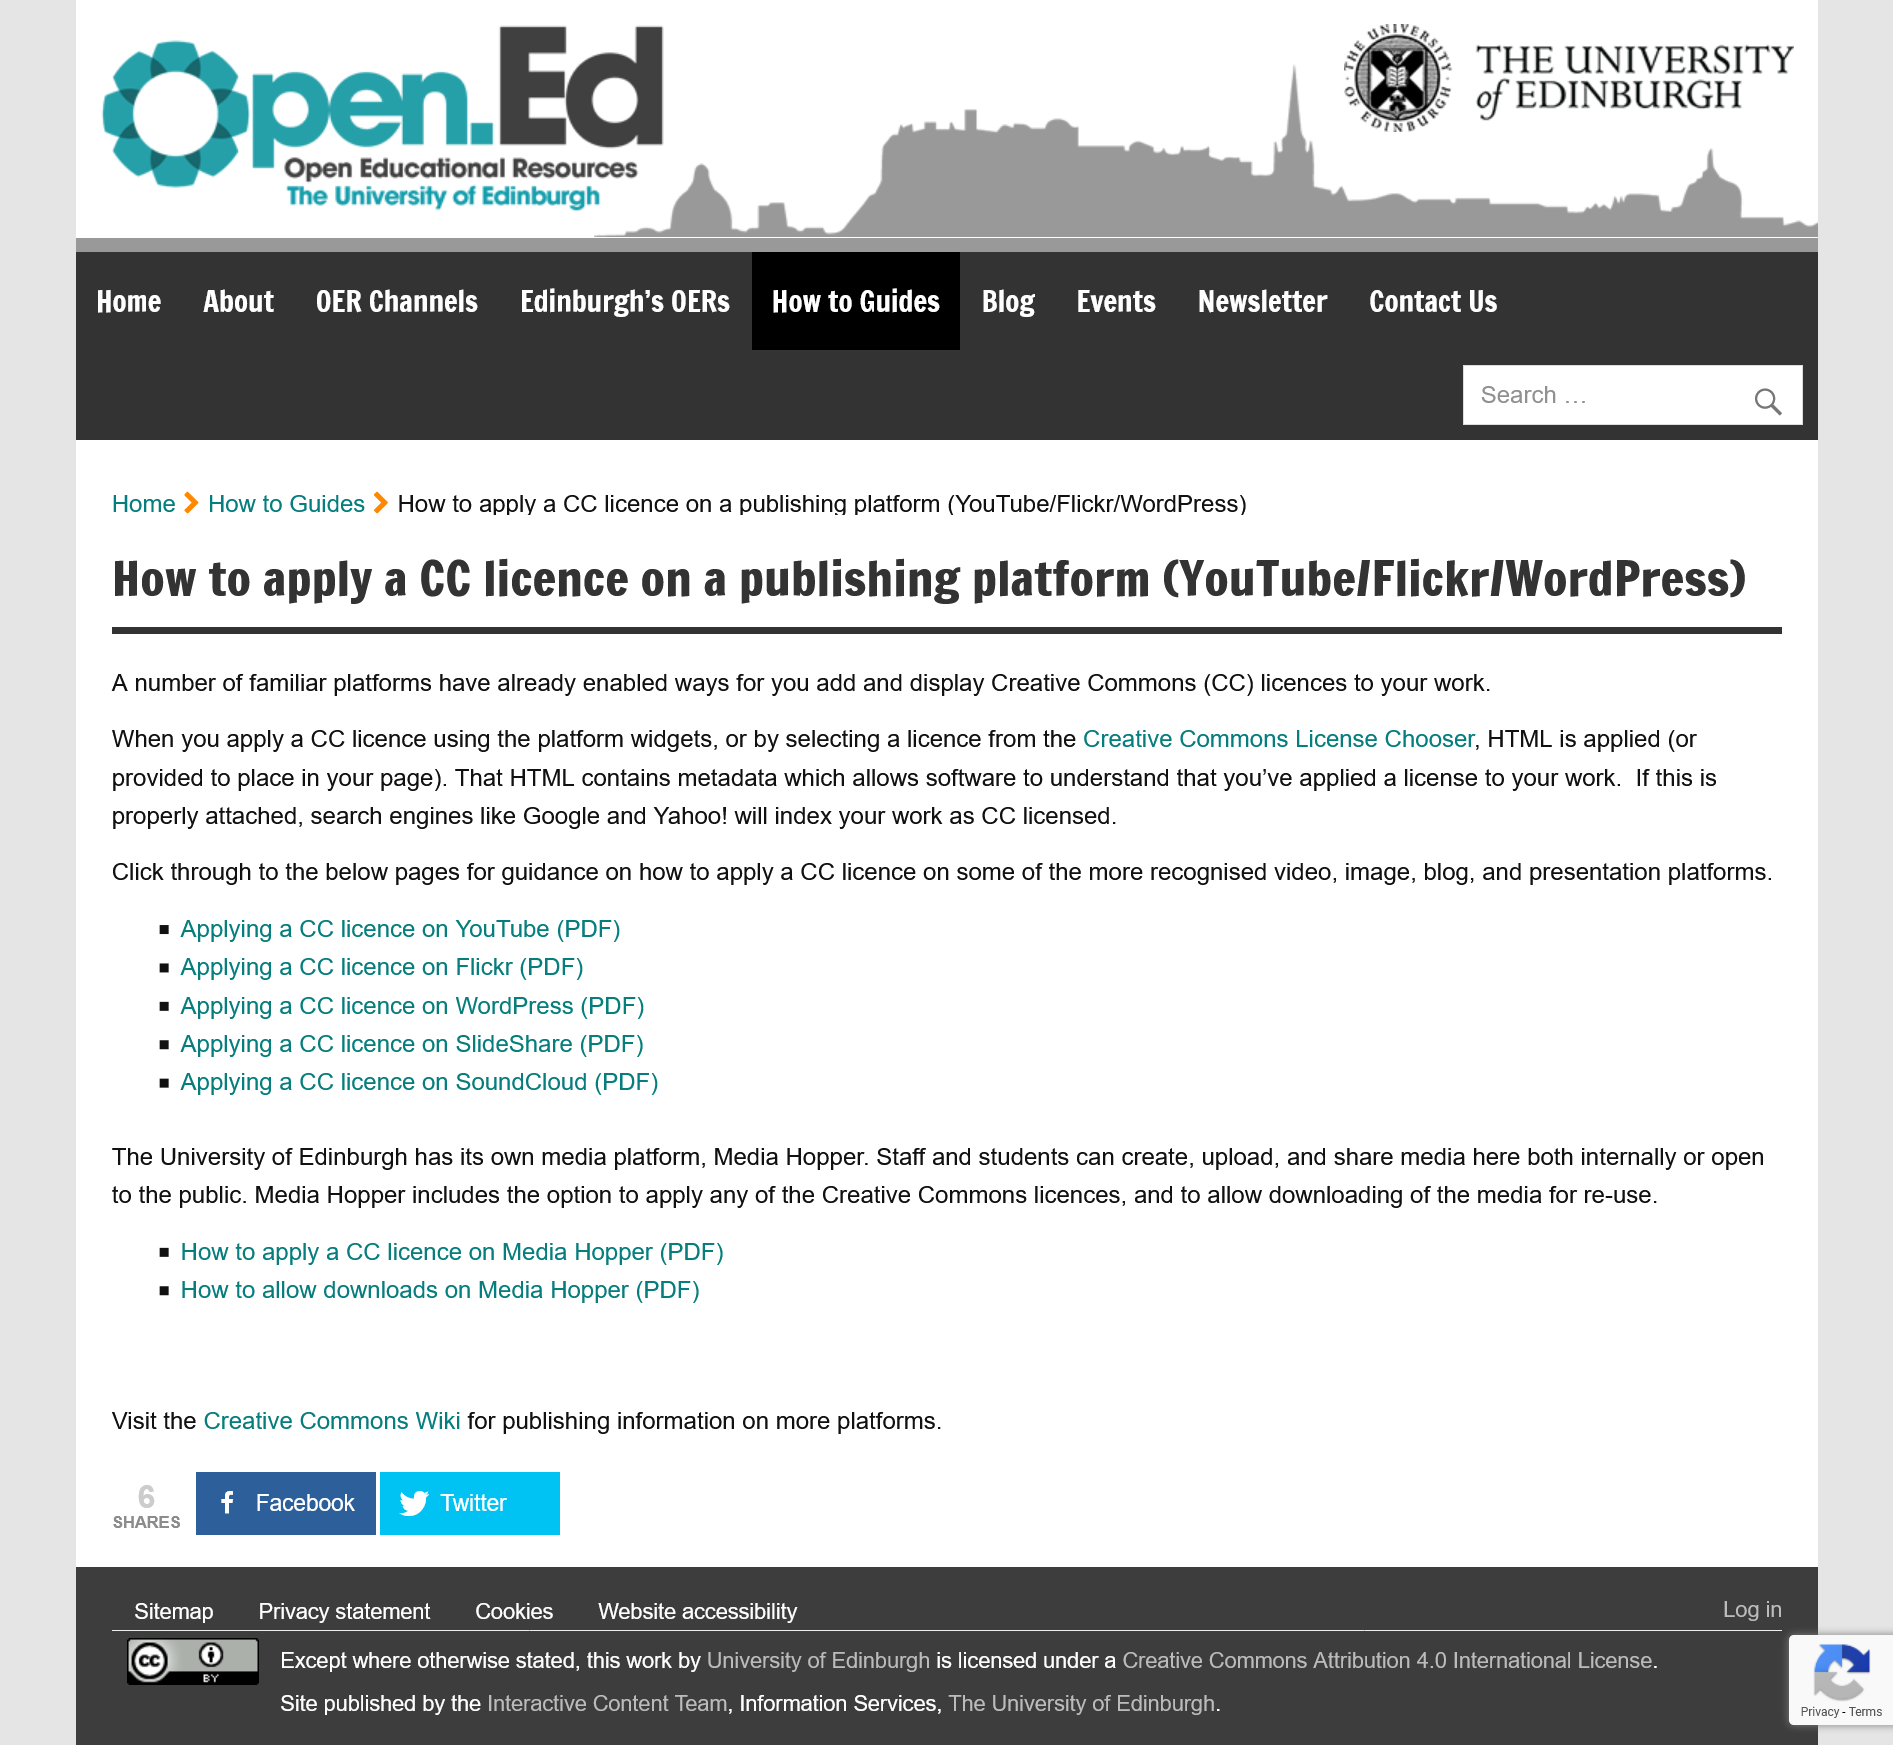List a handful of essential elements in this visual. The University of Edinburgh has a media platform called Media Hopper, which is unique to the institution. CC" is a abbreviation that stands for "Creative Commons. YouTube, Flickr, and WordPress are the three main familiar platforms that allow users to add and display Creative Commons licenses. 